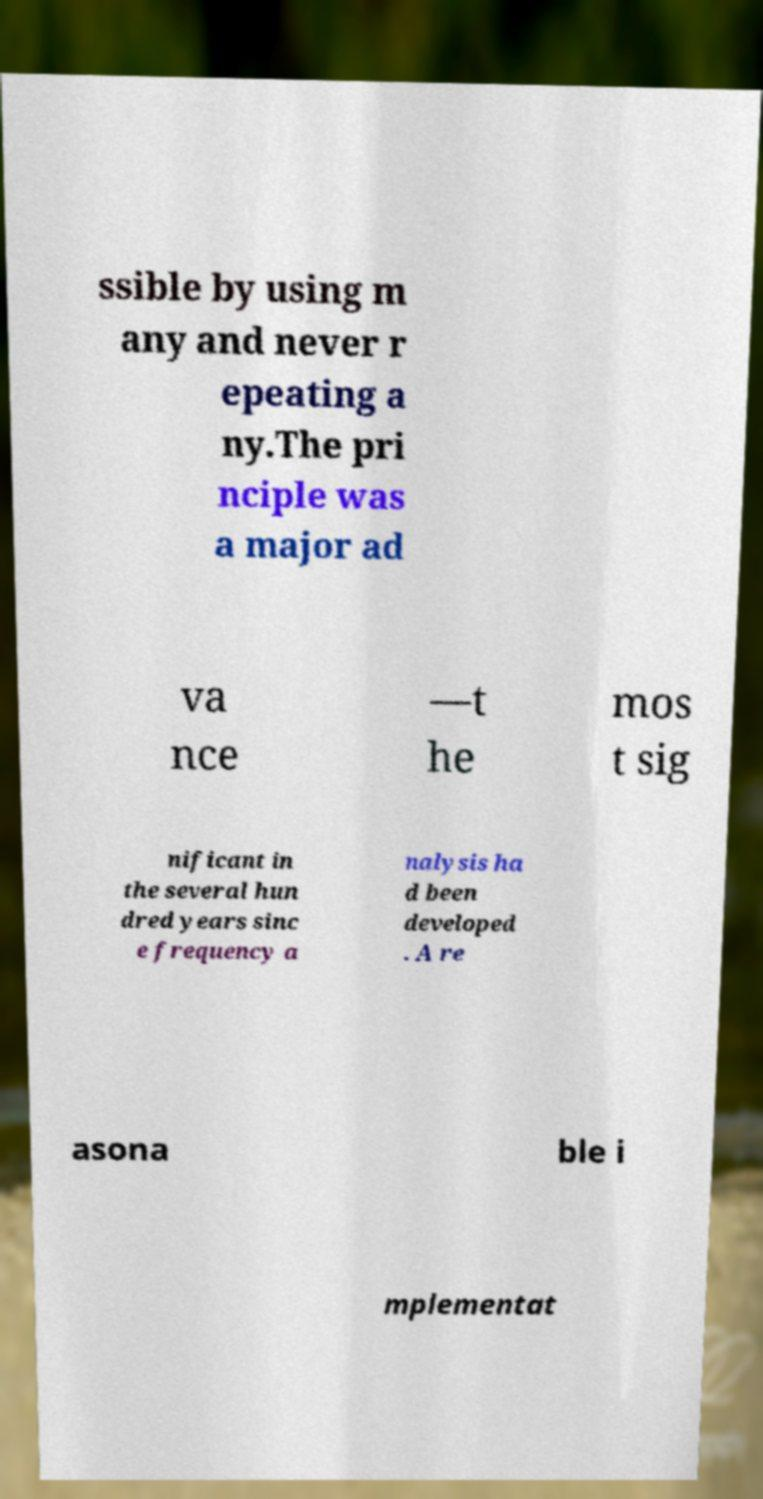There's text embedded in this image that I need extracted. Can you transcribe it verbatim? ssible by using m any and never r epeating a ny.The pri nciple was a major ad va nce —t he mos t sig nificant in the several hun dred years sinc e frequency a nalysis ha d been developed . A re asona ble i mplementat 